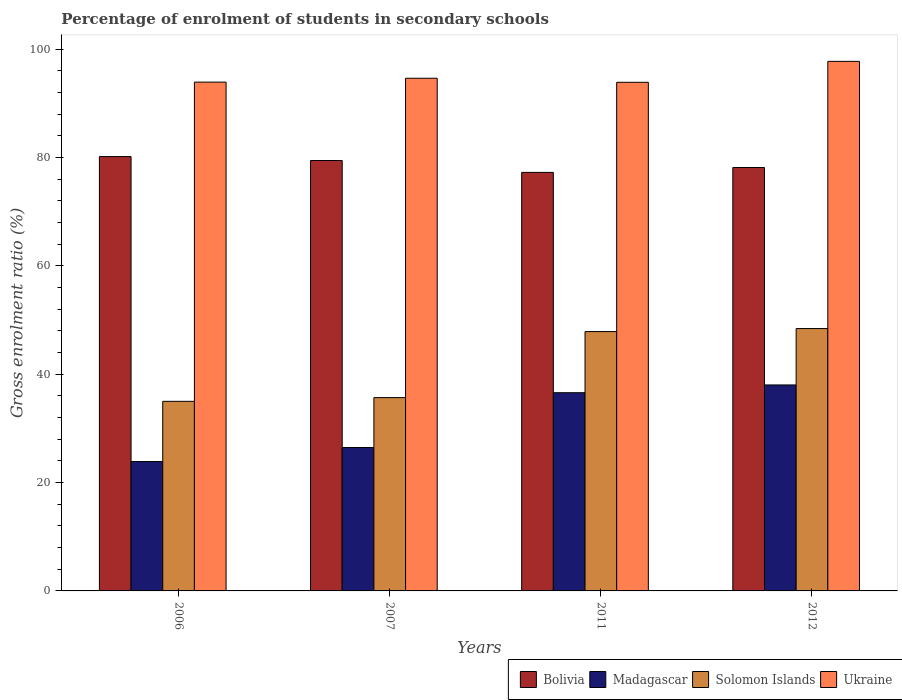How many different coloured bars are there?
Provide a succinct answer. 4. How many groups of bars are there?
Offer a very short reply. 4. Are the number of bars on each tick of the X-axis equal?
Provide a short and direct response. Yes. What is the percentage of students enrolled in secondary schools in Madagascar in 2012?
Make the answer very short. 38.03. Across all years, what is the maximum percentage of students enrolled in secondary schools in Solomon Islands?
Your answer should be very brief. 48.44. Across all years, what is the minimum percentage of students enrolled in secondary schools in Bolivia?
Ensure brevity in your answer.  77.27. In which year was the percentage of students enrolled in secondary schools in Ukraine maximum?
Your response must be concise. 2012. In which year was the percentage of students enrolled in secondary schools in Madagascar minimum?
Keep it short and to the point. 2006. What is the total percentage of students enrolled in secondary schools in Ukraine in the graph?
Provide a short and direct response. 380.27. What is the difference between the percentage of students enrolled in secondary schools in Ukraine in 2006 and that in 2007?
Provide a short and direct response. -0.72. What is the difference between the percentage of students enrolled in secondary schools in Ukraine in 2007 and the percentage of students enrolled in secondary schools in Madagascar in 2006?
Your response must be concise. 70.76. What is the average percentage of students enrolled in secondary schools in Ukraine per year?
Your response must be concise. 95.07. In the year 2006, what is the difference between the percentage of students enrolled in secondary schools in Madagascar and percentage of students enrolled in secondary schools in Solomon Islands?
Offer a very short reply. -11.11. What is the ratio of the percentage of students enrolled in secondary schools in Bolivia in 2007 to that in 2012?
Provide a succinct answer. 1.02. What is the difference between the highest and the second highest percentage of students enrolled in secondary schools in Madagascar?
Provide a short and direct response. 1.43. What is the difference between the highest and the lowest percentage of students enrolled in secondary schools in Madagascar?
Make the answer very short. 14.14. In how many years, is the percentage of students enrolled in secondary schools in Madagascar greater than the average percentage of students enrolled in secondary schools in Madagascar taken over all years?
Your answer should be compact. 2. What does the 2nd bar from the left in 2006 represents?
Offer a terse response. Madagascar. What does the 1st bar from the right in 2012 represents?
Make the answer very short. Ukraine. How many years are there in the graph?
Provide a short and direct response. 4. How many legend labels are there?
Your answer should be very brief. 4. What is the title of the graph?
Your response must be concise. Percentage of enrolment of students in secondary schools. Does "South Sudan" appear as one of the legend labels in the graph?
Offer a very short reply. No. What is the label or title of the X-axis?
Provide a succinct answer. Years. What is the Gross enrolment ratio (%) in Bolivia in 2006?
Ensure brevity in your answer.  80.2. What is the Gross enrolment ratio (%) of Madagascar in 2006?
Provide a short and direct response. 23.89. What is the Gross enrolment ratio (%) of Solomon Islands in 2006?
Your answer should be compact. 35. What is the Gross enrolment ratio (%) in Ukraine in 2006?
Ensure brevity in your answer.  93.94. What is the Gross enrolment ratio (%) in Bolivia in 2007?
Ensure brevity in your answer.  79.47. What is the Gross enrolment ratio (%) in Madagascar in 2007?
Your answer should be very brief. 26.48. What is the Gross enrolment ratio (%) of Solomon Islands in 2007?
Your response must be concise. 35.69. What is the Gross enrolment ratio (%) of Ukraine in 2007?
Your response must be concise. 94.66. What is the Gross enrolment ratio (%) of Bolivia in 2011?
Make the answer very short. 77.27. What is the Gross enrolment ratio (%) of Madagascar in 2011?
Offer a terse response. 36.6. What is the Gross enrolment ratio (%) in Solomon Islands in 2011?
Your answer should be very brief. 47.88. What is the Gross enrolment ratio (%) of Ukraine in 2011?
Keep it short and to the point. 93.91. What is the Gross enrolment ratio (%) of Bolivia in 2012?
Your response must be concise. 78.17. What is the Gross enrolment ratio (%) of Madagascar in 2012?
Provide a short and direct response. 38.03. What is the Gross enrolment ratio (%) in Solomon Islands in 2012?
Make the answer very short. 48.44. What is the Gross enrolment ratio (%) of Ukraine in 2012?
Give a very brief answer. 97.77. Across all years, what is the maximum Gross enrolment ratio (%) of Bolivia?
Your answer should be very brief. 80.2. Across all years, what is the maximum Gross enrolment ratio (%) in Madagascar?
Your answer should be compact. 38.03. Across all years, what is the maximum Gross enrolment ratio (%) in Solomon Islands?
Your response must be concise. 48.44. Across all years, what is the maximum Gross enrolment ratio (%) in Ukraine?
Your response must be concise. 97.77. Across all years, what is the minimum Gross enrolment ratio (%) of Bolivia?
Make the answer very short. 77.27. Across all years, what is the minimum Gross enrolment ratio (%) in Madagascar?
Give a very brief answer. 23.89. Across all years, what is the minimum Gross enrolment ratio (%) of Solomon Islands?
Your response must be concise. 35. Across all years, what is the minimum Gross enrolment ratio (%) of Ukraine?
Give a very brief answer. 93.91. What is the total Gross enrolment ratio (%) of Bolivia in the graph?
Your response must be concise. 315.1. What is the total Gross enrolment ratio (%) of Madagascar in the graph?
Your answer should be very brief. 124.99. What is the total Gross enrolment ratio (%) in Solomon Islands in the graph?
Keep it short and to the point. 167.01. What is the total Gross enrolment ratio (%) in Ukraine in the graph?
Offer a terse response. 380.27. What is the difference between the Gross enrolment ratio (%) in Bolivia in 2006 and that in 2007?
Provide a succinct answer. 0.73. What is the difference between the Gross enrolment ratio (%) in Madagascar in 2006 and that in 2007?
Provide a short and direct response. -2.59. What is the difference between the Gross enrolment ratio (%) of Solomon Islands in 2006 and that in 2007?
Your response must be concise. -0.69. What is the difference between the Gross enrolment ratio (%) in Ukraine in 2006 and that in 2007?
Offer a very short reply. -0.72. What is the difference between the Gross enrolment ratio (%) of Bolivia in 2006 and that in 2011?
Offer a very short reply. 2.92. What is the difference between the Gross enrolment ratio (%) of Madagascar in 2006 and that in 2011?
Ensure brevity in your answer.  -12.7. What is the difference between the Gross enrolment ratio (%) of Solomon Islands in 2006 and that in 2011?
Make the answer very short. -12.88. What is the difference between the Gross enrolment ratio (%) of Ukraine in 2006 and that in 2011?
Keep it short and to the point. 0.03. What is the difference between the Gross enrolment ratio (%) in Bolivia in 2006 and that in 2012?
Ensure brevity in your answer.  2.02. What is the difference between the Gross enrolment ratio (%) of Madagascar in 2006 and that in 2012?
Your response must be concise. -14.14. What is the difference between the Gross enrolment ratio (%) of Solomon Islands in 2006 and that in 2012?
Your answer should be compact. -13.44. What is the difference between the Gross enrolment ratio (%) in Ukraine in 2006 and that in 2012?
Provide a succinct answer. -3.83. What is the difference between the Gross enrolment ratio (%) in Bolivia in 2007 and that in 2011?
Your answer should be very brief. 2.19. What is the difference between the Gross enrolment ratio (%) in Madagascar in 2007 and that in 2011?
Ensure brevity in your answer.  -10.12. What is the difference between the Gross enrolment ratio (%) of Solomon Islands in 2007 and that in 2011?
Offer a very short reply. -12.19. What is the difference between the Gross enrolment ratio (%) of Ukraine in 2007 and that in 2011?
Give a very brief answer. 0.75. What is the difference between the Gross enrolment ratio (%) of Bolivia in 2007 and that in 2012?
Your answer should be very brief. 1.29. What is the difference between the Gross enrolment ratio (%) of Madagascar in 2007 and that in 2012?
Offer a terse response. -11.55. What is the difference between the Gross enrolment ratio (%) in Solomon Islands in 2007 and that in 2012?
Provide a succinct answer. -12.75. What is the difference between the Gross enrolment ratio (%) of Ukraine in 2007 and that in 2012?
Your answer should be very brief. -3.12. What is the difference between the Gross enrolment ratio (%) in Bolivia in 2011 and that in 2012?
Offer a very short reply. -0.9. What is the difference between the Gross enrolment ratio (%) of Madagascar in 2011 and that in 2012?
Provide a short and direct response. -1.43. What is the difference between the Gross enrolment ratio (%) of Solomon Islands in 2011 and that in 2012?
Offer a terse response. -0.56. What is the difference between the Gross enrolment ratio (%) in Ukraine in 2011 and that in 2012?
Provide a short and direct response. -3.87. What is the difference between the Gross enrolment ratio (%) in Bolivia in 2006 and the Gross enrolment ratio (%) in Madagascar in 2007?
Offer a terse response. 53.72. What is the difference between the Gross enrolment ratio (%) of Bolivia in 2006 and the Gross enrolment ratio (%) of Solomon Islands in 2007?
Make the answer very short. 44.51. What is the difference between the Gross enrolment ratio (%) in Bolivia in 2006 and the Gross enrolment ratio (%) in Ukraine in 2007?
Provide a succinct answer. -14.46. What is the difference between the Gross enrolment ratio (%) in Madagascar in 2006 and the Gross enrolment ratio (%) in Solomon Islands in 2007?
Ensure brevity in your answer.  -11.8. What is the difference between the Gross enrolment ratio (%) in Madagascar in 2006 and the Gross enrolment ratio (%) in Ukraine in 2007?
Give a very brief answer. -70.76. What is the difference between the Gross enrolment ratio (%) of Solomon Islands in 2006 and the Gross enrolment ratio (%) of Ukraine in 2007?
Make the answer very short. -59.65. What is the difference between the Gross enrolment ratio (%) in Bolivia in 2006 and the Gross enrolment ratio (%) in Madagascar in 2011?
Offer a very short reply. 43.6. What is the difference between the Gross enrolment ratio (%) of Bolivia in 2006 and the Gross enrolment ratio (%) of Solomon Islands in 2011?
Your response must be concise. 32.31. What is the difference between the Gross enrolment ratio (%) of Bolivia in 2006 and the Gross enrolment ratio (%) of Ukraine in 2011?
Keep it short and to the point. -13.71. What is the difference between the Gross enrolment ratio (%) in Madagascar in 2006 and the Gross enrolment ratio (%) in Solomon Islands in 2011?
Your response must be concise. -23.99. What is the difference between the Gross enrolment ratio (%) in Madagascar in 2006 and the Gross enrolment ratio (%) in Ukraine in 2011?
Your answer should be compact. -70.01. What is the difference between the Gross enrolment ratio (%) of Solomon Islands in 2006 and the Gross enrolment ratio (%) of Ukraine in 2011?
Your response must be concise. -58.9. What is the difference between the Gross enrolment ratio (%) of Bolivia in 2006 and the Gross enrolment ratio (%) of Madagascar in 2012?
Provide a succinct answer. 42.17. What is the difference between the Gross enrolment ratio (%) of Bolivia in 2006 and the Gross enrolment ratio (%) of Solomon Islands in 2012?
Make the answer very short. 31.76. What is the difference between the Gross enrolment ratio (%) of Bolivia in 2006 and the Gross enrolment ratio (%) of Ukraine in 2012?
Make the answer very short. -17.58. What is the difference between the Gross enrolment ratio (%) of Madagascar in 2006 and the Gross enrolment ratio (%) of Solomon Islands in 2012?
Provide a succinct answer. -24.55. What is the difference between the Gross enrolment ratio (%) in Madagascar in 2006 and the Gross enrolment ratio (%) in Ukraine in 2012?
Make the answer very short. -73.88. What is the difference between the Gross enrolment ratio (%) in Solomon Islands in 2006 and the Gross enrolment ratio (%) in Ukraine in 2012?
Offer a very short reply. -62.77. What is the difference between the Gross enrolment ratio (%) of Bolivia in 2007 and the Gross enrolment ratio (%) of Madagascar in 2011?
Ensure brevity in your answer.  42.87. What is the difference between the Gross enrolment ratio (%) of Bolivia in 2007 and the Gross enrolment ratio (%) of Solomon Islands in 2011?
Your answer should be compact. 31.59. What is the difference between the Gross enrolment ratio (%) of Bolivia in 2007 and the Gross enrolment ratio (%) of Ukraine in 2011?
Make the answer very short. -14.44. What is the difference between the Gross enrolment ratio (%) of Madagascar in 2007 and the Gross enrolment ratio (%) of Solomon Islands in 2011?
Make the answer very short. -21.4. What is the difference between the Gross enrolment ratio (%) of Madagascar in 2007 and the Gross enrolment ratio (%) of Ukraine in 2011?
Ensure brevity in your answer.  -67.43. What is the difference between the Gross enrolment ratio (%) in Solomon Islands in 2007 and the Gross enrolment ratio (%) in Ukraine in 2011?
Make the answer very short. -58.22. What is the difference between the Gross enrolment ratio (%) in Bolivia in 2007 and the Gross enrolment ratio (%) in Madagascar in 2012?
Ensure brevity in your answer.  41.44. What is the difference between the Gross enrolment ratio (%) in Bolivia in 2007 and the Gross enrolment ratio (%) in Solomon Islands in 2012?
Your answer should be very brief. 31.03. What is the difference between the Gross enrolment ratio (%) in Bolivia in 2007 and the Gross enrolment ratio (%) in Ukraine in 2012?
Make the answer very short. -18.31. What is the difference between the Gross enrolment ratio (%) in Madagascar in 2007 and the Gross enrolment ratio (%) in Solomon Islands in 2012?
Your answer should be compact. -21.96. What is the difference between the Gross enrolment ratio (%) in Madagascar in 2007 and the Gross enrolment ratio (%) in Ukraine in 2012?
Give a very brief answer. -71.29. What is the difference between the Gross enrolment ratio (%) in Solomon Islands in 2007 and the Gross enrolment ratio (%) in Ukraine in 2012?
Provide a succinct answer. -62.08. What is the difference between the Gross enrolment ratio (%) in Bolivia in 2011 and the Gross enrolment ratio (%) in Madagascar in 2012?
Give a very brief answer. 39.24. What is the difference between the Gross enrolment ratio (%) in Bolivia in 2011 and the Gross enrolment ratio (%) in Solomon Islands in 2012?
Your answer should be very brief. 28.83. What is the difference between the Gross enrolment ratio (%) in Bolivia in 2011 and the Gross enrolment ratio (%) in Ukraine in 2012?
Offer a terse response. -20.5. What is the difference between the Gross enrolment ratio (%) in Madagascar in 2011 and the Gross enrolment ratio (%) in Solomon Islands in 2012?
Your answer should be very brief. -11.84. What is the difference between the Gross enrolment ratio (%) of Madagascar in 2011 and the Gross enrolment ratio (%) of Ukraine in 2012?
Your answer should be very brief. -61.18. What is the difference between the Gross enrolment ratio (%) of Solomon Islands in 2011 and the Gross enrolment ratio (%) of Ukraine in 2012?
Your answer should be compact. -49.89. What is the average Gross enrolment ratio (%) in Bolivia per year?
Offer a very short reply. 78.78. What is the average Gross enrolment ratio (%) of Madagascar per year?
Ensure brevity in your answer.  31.25. What is the average Gross enrolment ratio (%) of Solomon Islands per year?
Offer a very short reply. 41.75. What is the average Gross enrolment ratio (%) in Ukraine per year?
Keep it short and to the point. 95.07. In the year 2006, what is the difference between the Gross enrolment ratio (%) in Bolivia and Gross enrolment ratio (%) in Madagascar?
Keep it short and to the point. 56.3. In the year 2006, what is the difference between the Gross enrolment ratio (%) of Bolivia and Gross enrolment ratio (%) of Solomon Islands?
Your response must be concise. 45.19. In the year 2006, what is the difference between the Gross enrolment ratio (%) of Bolivia and Gross enrolment ratio (%) of Ukraine?
Your answer should be compact. -13.74. In the year 2006, what is the difference between the Gross enrolment ratio (%) in Madagascar and Gross enrolment ratio (%) in Solomon Islands?
Offer a terse response. -11.11. In the year 2006, what is the difference between the Gross enrolment ratio (%) in Madagascar and Gross enrolment ratio (%) in Ukraine?
Give a very brief answer. -70.05. In the year 2006, what is the difference between the Gross enrolment ratio (%) of Solomon Islands and Gross enrolment ratio (%) of Ukraine?
Offer a very short reply. -58.94. In the year 2007, what is the difference between the Gross enrolment ratio (%) in Bolivia and Gross enrolment ratio (%) in Madagascar?
Your response must be concise. 52.99. In the year 2007, what is the difference between the Gross enrolment ratio (%) in Bolivia and Gross enrolment ratio (%) in Solomon Islands?
Keep it short and to the point. 43.78. In the year 2007, what is the difference between the Gross enrolment ratio (%) in Bolivia and Gross enrolment ratio (%) in Ukraine?
Ensure brevity in your answer.  -15.19. In the year 2007, what is the difference between the Gross enrolment ratio (%) in Madagascar and Gross enrolment ratio (%) in Solomon Islands?
Offer a terse response. -9.21. In the year 2007, what is the difference between the Gross enrolment ratio (%) of Madagascar and Gross enrolment ratio (%) of Ukraine?
Make the answer very short. -68.18. In the year 2007, what is the difference between the Gross enrolment ratio (%) in Solomon Islands and Gross enrolment ratio (%) in Ukraine?
Give a very brief answer. -58.97. In the year 2011, what is the difference between the Gross enrolment ratio (%) in Bolivia and Gross enrolment ratio (%) in Madagascar?
Offer a terse response. 40.68. In the year 2011, what is the difference between the Gross enrolment ratio (%) in Bolivia and Gross enrolment ratio (%) in Solomon Islands?
Make the answer very short. 29.39. In the year 2011, what is the difference between the Gross enrolment ratio (%) of Bolivia and Gross enrolment ratio (%) of Ukraine?
Your response must be concise. -16.64. In the year 2011, what is the difference between the Gross enrolment ratio (%) in Madagascar and Gross enrolment ratio (%) in Solomon Islands?
Your answer should be very brief. -11.28. In the year 2011, what is the difference between the Gross enrolment ratio (%) in Madagascar and Gross enrolment ratio (%) in Ukraine?
Give a very brief answer. -57.31. In the year 2011, what is the difference between the Gross enrolment ratio (%) of Solomon Islands and Gross enrolment ratio (%) of Ukraine?
Provide a short and direct response. -46.03. In the year 2012, what is the difference between the Gross enrolment ratio (%) in Bolivia and Gross enrolment ratio (%) in Madagascar?
Offer a terse response. 40.14. In the year 2012, what is the difference between the Gross enrolment ratio (%) in Bolivia and Gross enrolment ratio (%) in Solomon Islands?
Ensure brevity in your answer.  29.73. In the year 2012, what is the difference between the Gross enrolment ratio (%) in Bolivia and Gross enrolment ratio (%) in Ukraine?
Offer a very short reply. -19.6. In the year 2012, what is the difference between the Gross enrolment ratio (%) in Madagascar and Gross enrolment ratio (%) in Solomon Islands?
Make the answer very short. -10.41. In the year 2012, what is the difference between the Gross enrolment ratio (%) of Madagascar and Gross enrolment ratio (%) of Ukraine?
Make the answer very short. -59.75. In the year 2012, what is the difference between the Gross enrolment ratio (%) in Solomon Islands and Gross enrolment ratio (%) in Ukraine?
Keep it short and to the point. -49.33. What is the ratio of the Gross enrolment ratio (%) in Bolivia in 2006 to that in 2007?
Ensure brevity in your answer.  1.01. What is the ratio of the Gross enrolment ratio (%) of Madagascar in 2006 to that in 2007?
Ensure brevity in your answer.  0.9. What is the ratio of the Gross enrolment ratio (%) in Solomon Islands in 2006 to that in 2007?
Ensure brevity in your answer.  0.98. What is the ratio of the Gross enrolment ratio (%) in Bolivia in 2006 to that in 2011?
Offer a terse response. 1.04. What is the ratio of the Gross enrolment ratio (%) in Madagascar in 2006 to that in 2011?
Offer a very short reply. 0.65. What is the ratio of the Gross enrolment ratio (%) in Solomon Islands in 2006 to that in 2011?
Your response must be concise. 0.73. What is the ratio of the Gross enrolment ratio (%) of Bolivia in 2006 to that in 2012?
Provide a short and direct response. 1.03. What is the ratio of the Gross enrolment ratio (%) in Madagascar in 2006 to that in 2012?
Offer a terse response. 0.63. What is the ratio of the Gross enrolment ratio (%) of Solomon Islands in 2006 to that in 2012?
Ensure brevity in your answer.  0.72. What is the ratio of the Gross enrolment ratio (%) of Ukraine in 2006 to that in 2012?
Provide a short and direct response. 0.96. What is the ratio of the Gross enrolment ratio (%) in Bolivia in 2007 to that in 2011?
Provide a succinct answer. 1.03. What is the ratio of the Gross enrolment ratio (%) of Madagascar in 2007 to that in 2011?
Your answer should be compact. 0.72. What is the ratio of the Gross enrolment ratio (%) in Solomon Islands in 2007 to that in 2011?
Make the answer very short. 0.75. What is the ratio of the Gross enrolment ratio (%) in Bolivia in 2007 to that in 2012?
Ensure brevity in your answer.  1.02. What is the ratio of the Gross enrolment ratio (%) in Madagascar in 2007 to that in 2012?
Ensure brevity in your answer.  0.7. What is the ratio of the Gross enrolment ratio (%) in Solomon Islands in 2007 to that in 2012?
Your answer should be compact. 0.74. What is the ratio of the Gross enrolment ratio (%) in Ukraine in 2007 to that in 2012?
Offer a terse response. 0.97. What is the ratio of the Gross enrolment ratio (%) in Madagascar in 2011 to that in 2012?
Give a very brief answer. 0.96. What is the ratio of the Gross enrolment ratio (%) in Solomon Islands in 2011 to that in 2012?
Offer a terse response. 0.99. What is the ratio of the Gross enrolment ratio (%) in Ukraine in 2011 to that in 2012?
Offer a terse response. 0.96. What is the difference between the highest and the second highest Gross enrolment ratio (%) of Bolivia?
Offer a terse response. 0.73. What is the difference between the highest and the second highest Gross enrolment ratio (%) of Madagascar?
Offer a very short reply. 1.43. What is the difference between the highest and the second highest Gross enrolment ratio (%) in Solomon Islands?
Offer a terse response. 0.56. What is the difference between the highest and the second highest Gross enrolment ratio (%) in Ukraine?
Make the answer very short. 3.12. What is the difference between the highest and the lowest Gross enrolment ratio (%) in Bolivia?
Provide a short and direct response. 2.92. What is the difference between the highest and the lowest Gross enrolment ratio (%) in Madagascar?
Ensure brevity in your answer.  14.14. What is the difference between the highest and the lowest Gross enrolment ratio (%) of Solomon Islands?
Make the answer very short. 13.44. What is the difference between the highest and the lowest Gross enrolment ratio (%) of Ukraine?
Provide a short and direct response. 3.87. 